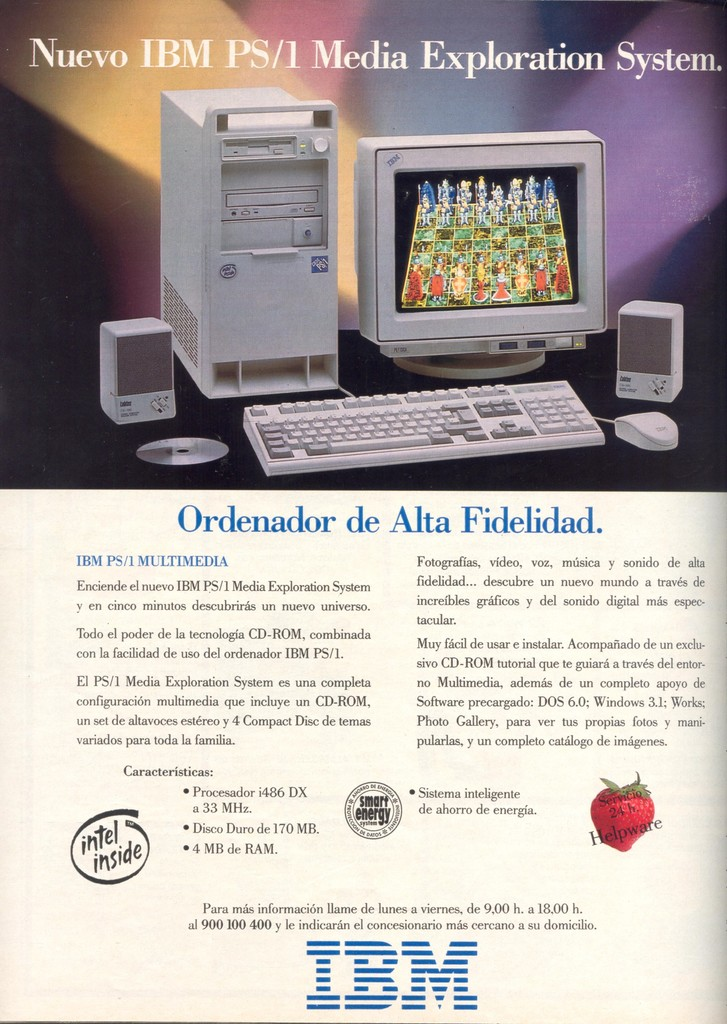Can you describe the main features of this image for me? The image is an advertisement for the Nuevo IBM PS/1 Media Exploration System, aimed at presenting this computer as a state-of-the-art technology for multimedia applications. The ad features a clear image of the computer alongside its accessories: a monitor displaying vibrant chess graphics, a keyboard, and a mouse. Additionally, it includes a speaker and a CD-ROM, emphasizing the system's audio-visual capabilities.

Prominent branding includes the IBM and Intel logos, showcasing their partnership in this system. The red wax seal with 'IBM' symbolizes authenticity and quality assurance. The text highlights features like a 486 DX processor at 33 MHz, 170 MB hard drive, and 4 MB of RAM, positioned as perfect for households. It also mentions software support with programs like Photo Gallery and Works 3.1, enhancing its appeal to families and media enthusiasts. The ad closes with contact information, suggesting availability and customer support. 